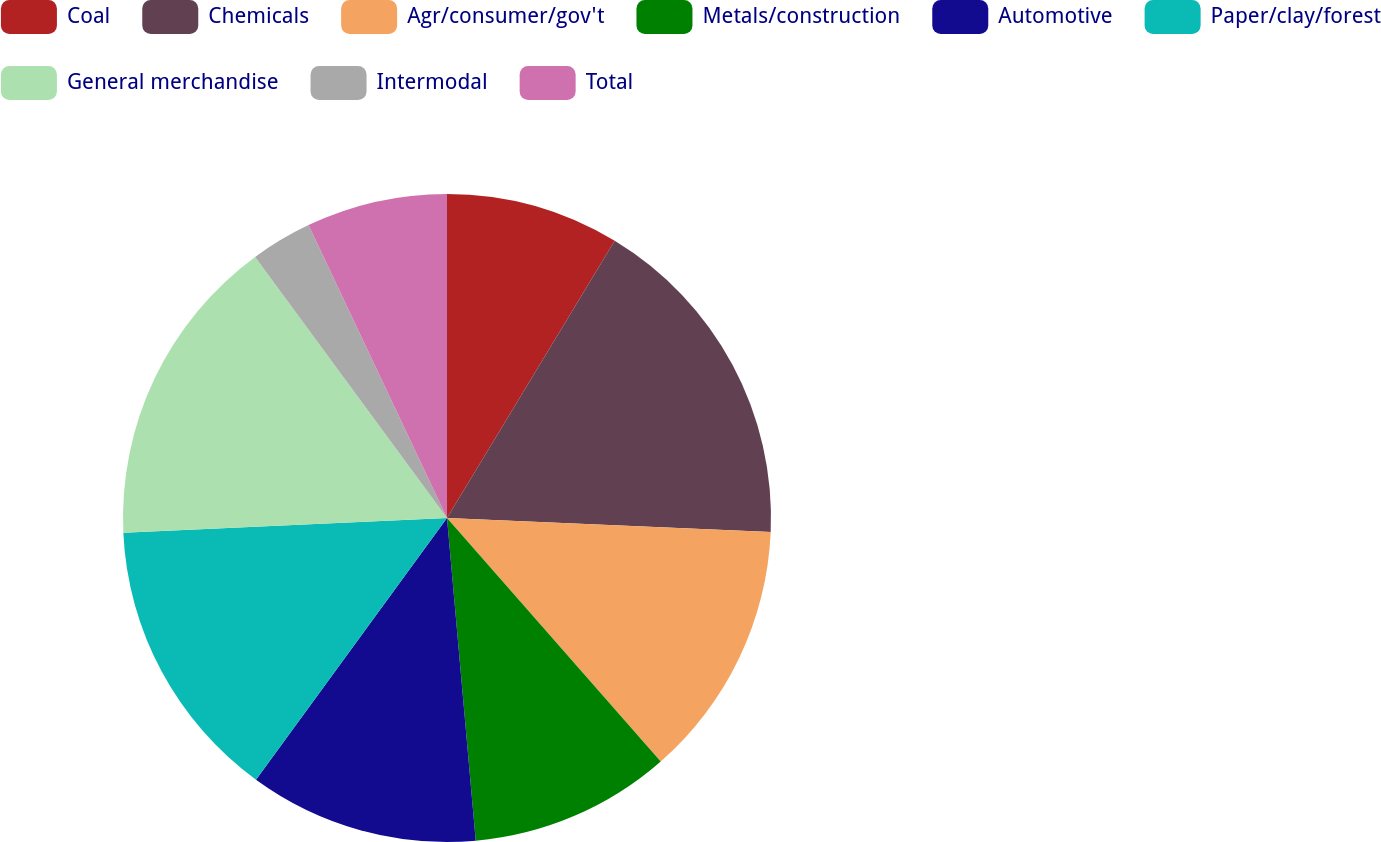<chart> <loc_0><loc_0><loc_500><loc_500><pie_chart><fcel>Coal<fcel>Chemicals<fcel>Agr/consumer/gov't<fcel>Metals/construction<fcel>Automotive<fcel>Paper/clay/forest<fcel>General merchandise<fcel>Intermodal<fcel>Total<nl><fcel>8.66%<fcel>17.03%<fcel>12.85%<fcel>10.05%<fcel>11.45%<fcel>14.24%<fcel>15.64%<fcel>3.06%<fcel>7.03%<nl></chart> 